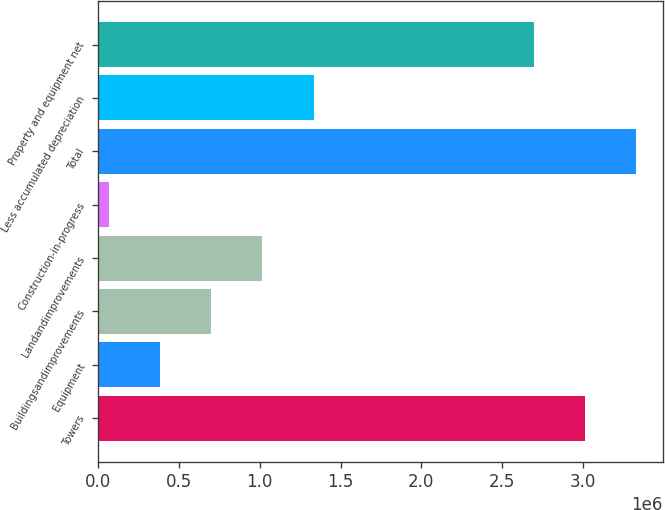Convert chart. <chart><loc_0><loc_0><loc_500><loc_500><bar_chart><fcel>Towers<fcel>Equipment<fcel>Buildingsandimprovements<fcel>Landandimprovements<fcel>Construction-in-progress<fcel>Total<fcel>Less accumulated depreciation<fcel>Property and equipment net<nl><fcel>3.01227e+06<fcel>381023<fcel>698291<fcel>1.01556e+06<fcel>63755<fcel>3.32953e+06<fcel>1.33283e+06<fcel>2.695e+06<nl></chart> 